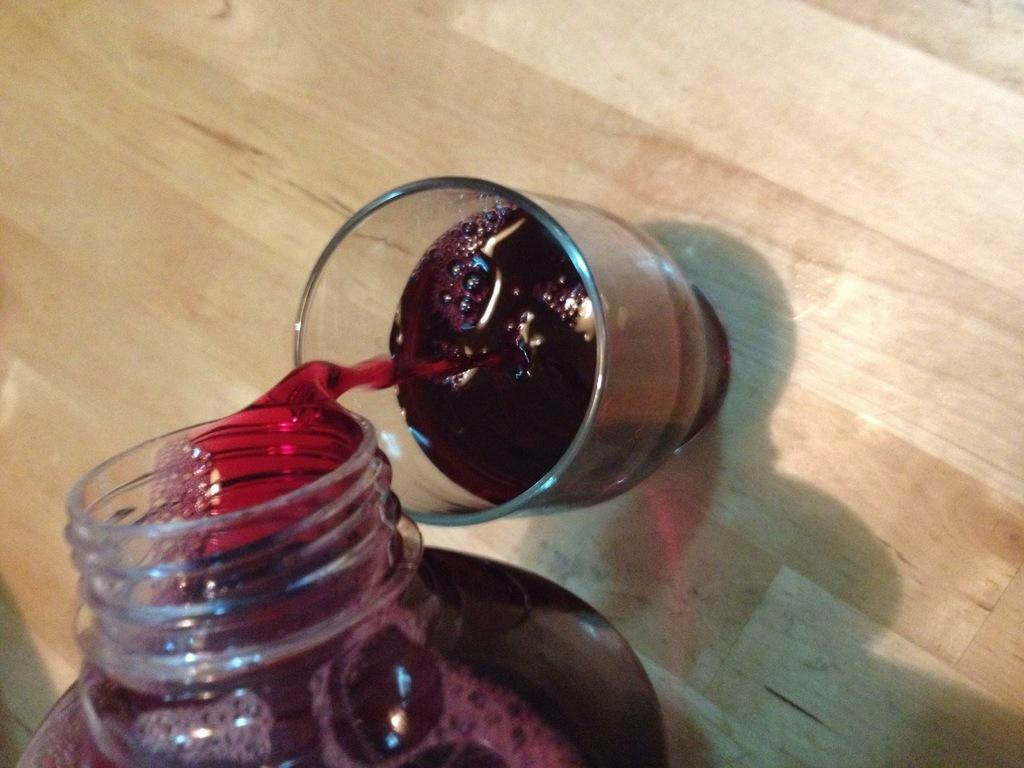What type of container is visible in the image? There is a glass in the image. What other type of container can be seen in the image? There is a bottle in the image. What type of apparatus is being used to attempt to gain approval in the image? There is no apparatus or attempt to gain approval present in the image; it only features a glass and a bottle. 